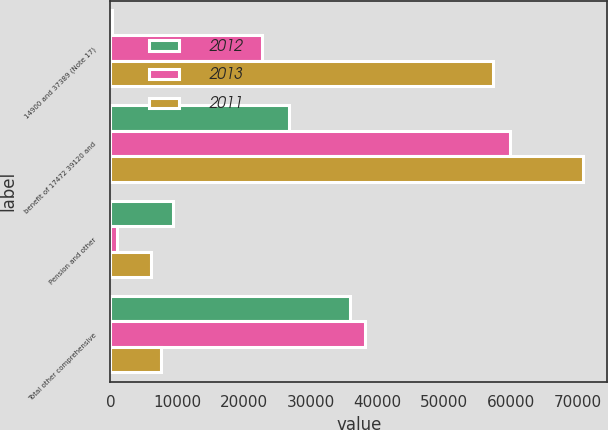Convert chart. <chart><loc_0><loc_0><loc_500><loc_500><stacked_bar_chart><ecel><fcel>14900 and 37389 (Note 17)<fcel>benefit of 17472 39120 and<fcel>Pension and other<fcel>Total other comprehensive<nl><fcel>2012<fcel>213<fcel>26747<fcel>9421<fcel>35955<nl><fcel>2013<fcel>22763<fcel>59887<fcel>1031<fcel>38155<nl><fcel>2011<fcel>57271<fcel>70902<fcel>6026<fcel>7605<nl></chart> 